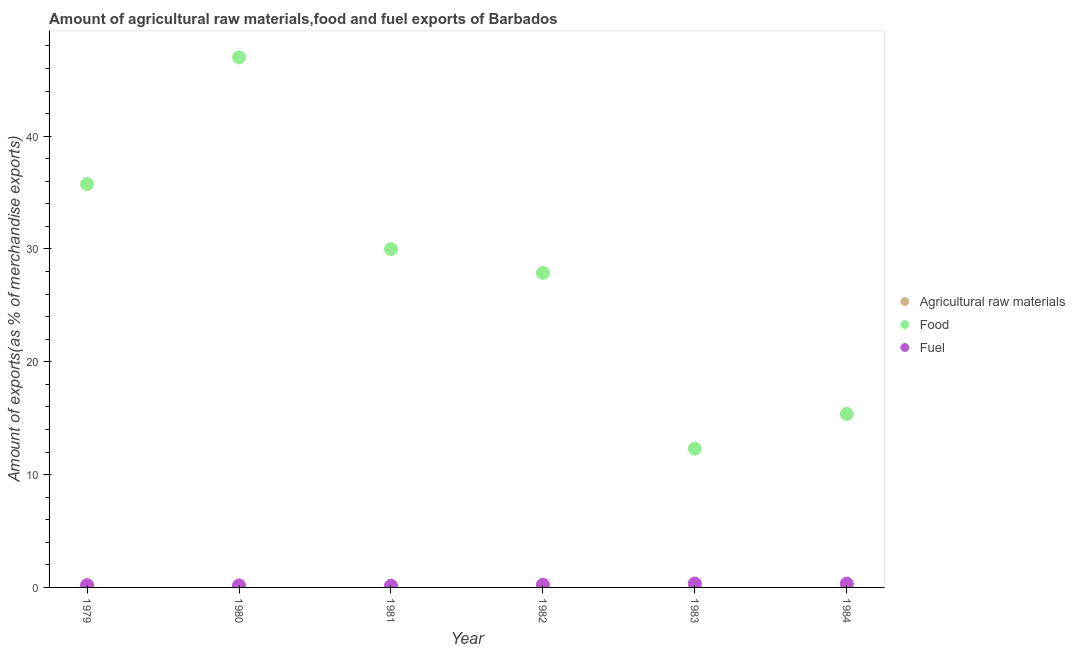What is the percentage of fuel exports in 1984?
Your answer should be very brief. 0.33. Across all years, what is the maximum percentage of raw materials exports?
Make the answer very short. 0.15. Across all years, what is the minimum percentage of food exports?
Your answer should be very brief. 12.3. In which year was the percentage of food exports minimum?
Ensure brevity in your answer.  1983. What is the total percentage of food exports in the graph?
Provide a short and direct response. 168.29. What is the difference between the percentage of raw materials exports in 1979 and that in 1981?
Keep it short and to the point. 0.13. What is the difference between the percentage of fuel exports in 1979 and the percentage of raw materials exports in 1984?
Your answer should be very brief. 0.19. What is the average percentage of raw materials exports per year?
Give a very brief answer. 0.04. In the year 1982, what is the difference between the percentage of raw materials exports and percentage of fuel exports?
Offer a terse response. -0.23. What is the ratio of the percentage of food exports in 1980 to that in 1983?
Provide a short and direct response. 3.82. Is the percentage of food exports in 1980 less than that in 1982?
Your answer should be compact. No. What is the difference between the highest and the second highest percentage of food exports?
Your answer should be compact. 11.24. What is the difference between the highest and the lowest percentage of raw materials exports?
Provide a short and direct response. 0.14. In how many years, is the percentage of food exports greater than the average percentage of food exports taken over all years?
Offer a very short reply. 3. Is it the case that in every year, the sum of the percentage of raw materials exports and percentage of food exports is greater than the percentage of fuel exports?
Make the answer very short. Yes. Is the percentage of raw materials exports strictly greater than the percentage of food exports over the years?
Make the answer very short. No. How many years are there in the graph?
Keep it short and to the point. 6. What is the difference between two consecutive major ticks on the Y-axis?
Make the answer very short. 10. Are the values on the major ticks of Y-axis written in scientific E-notation?
Make the answer very short. No. Does the graph contain any zero values?
Keep it short and to the point. No. Does the graph contain grids?
Ensure brevity in your answer.  No. What is the title of the graph?
Keep it short and to the point. Amount of agricultural raw materials,food and fuel exports of Barbados. Does "Taxes on international trade" appear as one of the legend labels in the graph?
Provide a short and direct response. No. What is the label or title of the X-axis?
Your answer should be very brief. Year. What is the label or title of the Y-axis?
Give a very brief answer. Amount of exports(as % of merchandise exports). What is the Amount of exports(as % of merchandise exports) in Agricultural raw materials in 1979?
Your answer should be compact. 0.15. What is the Amount of exports(as % of merchandise exports) in Food in 1979?
Your answer should be compact. 35.75. What is the Amount of exports(as % of merchandise exports) of Fuel in 1979?
Ensure brevity in your answer.  0.2. What is the Amount of exports(as % of merchandise exports) of Agricultural raw materials in 1980?
Make the answer very short. 0.06. What is the Amount of exports(as % of merchandise exports) in Food in 1980?
Your response must be concise. 46.99. What is the Amount of exports(as % of merchandise exports) of Fuel in 1980?
Your answer should be compact. 0.18. What is the Amount of exports(as % of merchandise exports) in Agricultural raw materials in 1981?
Make the answer very short. 0.02. What is the Amount of exports(as % of merchandise exports) in Food in 1981?
Offer a terse response. 29.98. What is the Amount of exports(as % of merchandise exports) of Fuel in 1981?
Ensure brevity in your answer.  0.15. What is the Amount of exports(as % of merchandise exports) of Agricultural raw materials in 1982?
Make the answer very short. 0.01. What is the Amount of exports(as % of merchandise exports) of Food in 1982?
Give a very brief answer. 27.88. What is the Amount of exports(as % of merchandise exports) of Fuel in 1982?
Keep it short and to the point. 0.24. What is the Amount of exports(as % of merchandise exports) of Agricultural raw materials in 1983?
Keep it short and to the point. 0.01. What is the Amount of exports(as % of merchandise exports) in Food in 1983?
Keep it short and to the point. 12.3. What is the Amount of exports(as % of merchandise exports) in Fuel in 1983?
Keep it short and to the point. 0.35. What is the Amount of exports(as % of merchandise exports) in Agricultural raw materials in 1984?
Keep it short and to the point. 0.01. What is the Amount of exports(as % of merchandise exports) in Food in 1984?
Make the answer very short. 15.38. What is the Amount of exports(as % of merchandise exports) in Fuel in 1984?
Ensure brevity in your answer.  0.33. Across all years, what is the maximum Amount of exports(as % of merchandise exports) in Agricultural raw materials?
Offer a terse response. 0.15. Across all years, what is the maximum Amount of exports(as % of merchandise exports) in Food?
Your answer should be very brief. 46.99. Across all years, what is the maximum Amount of exports(as % of merchandise exports) of Fuel?
Provide a short and direct response. 0.35. Across all years, what is the minimum Amount of exports(as % of merchandise exports) in Agricultural raw materials?
Your answer should be compact. 0.01. Across all years, what is the minimum Amount of exports(as % of merchandise exports) in Food?
Your answer should be compact. 12.3. Across all years, what is the minimum Amount of exports(as % of merchandise exports) of Fuel?
Make the answer very short. 0.15. What is the total Amount of exports(as % of merchandise exports) in Agricultural raw materials in the graph?
Your response must be concise. 0.26. What is the total Amount of exports(as % of merchandise exports) of Food in the graph?
Provide a short and direct response. 168.29. What is the total Amount of exports(as % of merchandise exports) of Fuel in the graph?
Your answer should be very brief. 1.45. What is the difference between the Amount of exports(as % of merchandise exports) of Agricultural raw materials in 1979 and that in 1980?
Give a very brief answer. 0.09. What is the difference between the Amount of exports(as % of merchandise exports) in Food in 1979 and that in 1980?
Make the answer very short. -11.24. What is the difference between the Amount of exports(as % of merchandise exports) of Fuel in 1979 and that in 1980?
Your answer should be very brief. 0.02. What is the difference between the Amount of exports(as % of merchandise exports) in Agricultural raw materials in 1979 and that in 1981?
Your response must be concise. 0.13. What is the difference between the Amount of exports(as % of merchandise exports) of Food in 1979 and that in 1981?
Your response must be concise. 5.76. What is the difference between the Amount of exports(as % of merchandise exports) of Fuel in 1979 and that in 1981?
Make the answer very short. 0.05. What is the difference between the Amount of exports(as % of merchandise exports) in Agricultural raw materials in 1979 and that in 1982?
Your answer should be compact. 0.14. What is the difference between the Amount of exports(as % of merchandise exports) of Food in 1979 and that in 1982?
Your answer should be compact. 7.87. What is the difference between the Amount of exports(as % of merchandise exports) of Fuel in 1979 and that in 1982?
Make the answer very short. -0.04. What is the difference between the Amount of exports(as % of merchandise exports) in Agricultural raw materials in 1979 and that in 1983?
Offer a terse response. 0.14. What is the difference between the Amount of exports(as % of merchandise exports) of Food in 1979 and that in 1983?
Ensure brevity in your answer.  23.44. What is the difference between the Amount of exports(as % of merchandise exports) of Fuel in 1979 and that in 1983?
Give a very brief answer. -0.15. What is the difference between the Amount of exports(as % of merchandise exports) of Agricultural raw materials in 1979 and that in 1984?
Offer a terse response. 0.14. What is the difference between the Amount of exports(as % of merchandise exports) of Food in 1979 and that in 1984?
Ensure brevity in your answer.  20.37. What is the difference between the Amount of exports(as % of merchandise exports) in Fuel in 1979 and that in 1984?
Provide a succinct answer. -0.13. What is the difference between the Amount of exports(as % of merchandise exports) of Agricultural raw materials in 1980 and that in 1981?
Give a very brief answer. 0.04. What is the difference between the Amount of exports(as % of merchandise exports) in Food in 1980 and that in 1981?
Your answer should be very brief. 17.01. What is the difference between the Amount of exports(as % of merchandise exports) of Fuel in 1980 and that in 1981?
Ensure brevity in your answer.  0.02. What is the difference between the Amount of exports(as % of merchandise exports) of Agricultural raw materials in 1980 and that in 1982?
Keep it short and to the point. 0.05. What is the difference between the Amount of exports(as % of merchandise exports) of Food in 1980 and that in 1982?
Keep it short and to the point. 19.11. What is the difference between the Amount of exports(as % of merchandise exports) of Fuel in 1980 and that in 1982?
Offer a terse response. -0.06. What is the difference between the Amount of exports(as % of merchandise exports) in Agricultural raw materials in 1980 and that in 1983?
Your answer should be very brief. 0.05. What is the difference between the Amount of exports(as % of merchandise exports) in Food in 1980 and that in 1983?
Offer a very short reply. 34.68. What is the difference between the Amount of exports(as % of merchandise exports) of Fuel in 1980 and that in 1983?
Provide a short and direct response. -0.17. What is the difference between the Amount of exports(as % of merchandise exports) of Agricultural raw materials in 1980 and that in 1984?
Give a very brief answer. 0.05. What is the difference between the Amount of exports(as % of merchandise exports) of Food in 1980 and that in 1984?
Provide a succinct answer. 31.61. What is the difference between the Amount of exports(as % of merchandise exports) in Fuel in 1980 and that in 1984?
Offer a terse response. -0.15. What is the difference between the Amount of exports(as % of merchandise exports) in Food in 1981 and that in 1982?
Offer a very short reply. 2.1. What is the difference between the Amount of exports(as % of merchandise exports) of Fuel in 1981 and that in 1982?
Ensure brevity in your answer.  -0.09. What is the difference between the Amount of exports(as % of merchandise exports) of Agricultural raw materials in 1981 and that in 1983?
Offer a very short reply. 0.01. What is the difference between the Amount of exports(as % of merchandise exports) of Food in 1981 and that in 1983?
Ensure brevity in your answer.  17.68. What is the difference between the Amount of exports(as % of merchandise exports) of Fuel in 1981 and that in 1983?
Provide a succinct answer. -0.19. What is the difference between the Amount of exports(as % of merchandise exports) of Agricultural raw materials in 1981 and that in 1984?
Keep it short and to the point. 0.01. What is the difference between the Amount of exports(as % of merchandise exports) of Food in 1981 and that in 1984?
Keep it short and to the point. 14.6. What is the difference between the Amount of exports(as % of merchandise exports) in Fuel in 1981 and that in 1984?
Offer a terse response. -0.18. What is the difference between the Amount of exports(as % of merchandise exports) of Agricultural raw materials in 1982 and that in 1983?
Make the answer very short. 0. What is the difference between the Amount of exports(as % of merchandise exports) in Food in 1982 and that in 1983?
Provide a succinct answer. 15.58. What is the difference between the Amount of exports(as % of merchandise exports) in Fuel in 1982 and that in 1983?
Provide a short and direct response. -0.11. What is the difference between the Amount of exports(as % of merchandise exports) in Agricultural raw materials in 1982 and that in 1984?
Give a very brief answer. -0. What is the difference between the Amount of exports(as % of merchandise exports) in Food in 1982 and that in 1984?
Make the answer very short. 12.5. What is the difference between the Amount of exports(as % of merchandise exports) in Fuel in 1982 and that in 1984?
Offer a very short reply. -0.09. What is the difference between the Amount of exports(as % of merchandise exports) of Agricultural raw materials in 1983 and that in 1984?
Your answer should be compact. -0. What is the difference between the Amount of exports(as % of merchandise exports) in Food in 1983 and that in 1984?
Your answer should be very brief. -3.08. What is the difference between the Amount of exports(as % of merchandise exports) in Fuel in 1983 and that in 1984?
Keep it short and to the point. 0.02. What is the difference between the Amount of exports(as % of merchandise exports) in Agricultural raw materials in 1979 and the Amount of exports(as % of merchandise exports) in Food in 1980?
Your answer should be compact. -46.84. What is the difference between the Amount of exports(as % of merchandise exports) in Agricultural raw materials in 1979 and the Amount of exports(as % of merchandise exports) in Fuel in 1980?
Keep it short and to the point. -0.03. What is the difference between the Amount of exports(as % of merchandise exports) of Food in 1979 and the Amount of exports(as % of merchandise exports) of Fuel in 1980?
Keep it short and to the point. 35.57. What is the difference between the Amount of exports(as % of merchandise exports) of Agricultural raw materials in 1979 and the Amount of exports(as % of merchandise exports) of Food in 1981?
Give a very brief answer. -29.83. What is the difference between the Amount of exports(as % of merchandise exports) in Agricultural raw materials in 1979 and the Amount of exports(as % of merchandise exports) in Fuel in 1981?
Ensure brevity in your answer.  -0. What is the difference between the Amount of exports(as % of merchandise exports) in Food in 1979 and the Amount of exports(as % of merchandise exports) in Fuel in 1981?
Provide a short and direct response. 35.6. What is the difference between the Amount of exports(as % of merchandise exports) of Agricultural raw materials in 1979 and the Amount of exports(as % of merchandise exports) of Food in 1982?
Give a very brief answer. -27.73. What is the difference between the Amount of exports(as % of merchandise exports) of Agricultural raw materials in 1979 and the Amount of exports(as % of merchandise exports) of Fuel in 1982?
Give a very brief answer. -0.09. What is the difference between the Amount of exports(as % of merchandise exports) of Food in 1979 and the Amount of exports(as % of merchandise exports) of Fuel in 1982?
Give a very brief answer. 35.51. What is the difference between the Amount of exports(as % of merchandise exports) of Agricultural raw materials in 1979 and the Amount of exports(as % of merchandise exports) of Food in 1983?
Your answer should be compact. -12.16. What is the difference between the Amount of exports(as % of merchandise exports) of Agricultural raw materials in 1979 and the Amount of exports(as % of merchandise exports) of Fuel in 1983?
Your answer should be very brief. -0.2. What is the difference between the Amount of exports(as % of merchandise exports) of Food in 1979 and the Amount of exports(as % of merchandise exports) of Fuel in 1983?
Ensure brevity in your answer.  35.4. What is the difference between the Amount of exports(as % of merchandise exports) of Agricultural raw materials in 1979 and the Amount of exports(as % of merchandise exports) of Food in 1984?
Provide a short and direct response. -15.23. What is the difference between the Amount of exports(as % of merchandise exports) of Agricultural raw materials in 1979 and the Amount of exports(as % of merchandise exports) of Fuel in 1984?
Your response must be concise. -0.18. What is the difference between the Amount of exports(as % of merchandise exports) of Food in 1979 and the Amount of exports(as % of merchandise exports) of Fuel in 1984?
Give a very brief answer. 35.42. What is the difference between the Amount of exports(as % of merchandise exports) in Agricultural raw materials in 1980 and the Amount of exports(as % of merchandise exports) in Food in 1981?
Offer a terse response. -29.93. What is the difference between the Amount of exports(as % of merchandise exports) of Agricultural raw materials in 1980 and the Amount of exports(as % of merchandise exports) of Fuel in 1981?
Your answer should be very brief. -0.09. What is the difference between the Amount of exports(as % of merchandise exports) in Food in 1980 and the Amount of exports(as % of merchandise exports) in Fuel in 1981?
Make the answer very short. 46.84. What is the difference between the Amount of exports(as % of merchandise exports) in Agricultural raw materials in 1980 and the Amount of exports(as % of merchandise exports) in Food in 1982?
Give a very brief answer. -27.82. What is the difference between the Amount of exports(as % of merchandise exports) in Agricultural raw materials in 1980 and the Amount of exports(as % of merchandise exports) in Fuel in 1982?
Provide a short and direct response. -0.18. What is the difference between the Amount of exports(as % of merchandise exports) in Food in 1980 and the Amount of exports(as % of merchandise exports) in Fuel in 1982?
Make the answer very short. 46.75. What is the difference between the Amount of exports(as % of merchandise exports) of Agricultural raw materials in 1980 and the Amount of exports(as % of merchandise exports) of Food in 1983?
Your answer should be very brief. -12.25. What is the difference between the Amount of exports(as % of merchandise exports) in Agricultural raw materials in 1980 and the Amount of exports(as % of merchandise exports) in Fuel in 1983?
Make the answer very short. -0.29. What is the difference between the Amount of exports(as % of merchandise exports) of Food in 1980 and the Amount of exports(as % of merchandise exports) of Fuel in 1983?
Keep it short and to the point. 46.64. What is the difference between the Amount of exports(as % of merchandise exports) of Agricultural raw materials in 1980 and the Amount of exports(as % of merchandise exports) of Food in 1984?
Offer a terse response. -15.32. What is the difference between the Amount of exports(as % of merchandise exports) of Agricultural raw materials in 1980 and the Amount of exports(as % of merchandise exports) of Fuel in 1984?
Offer a very short reply. -0.27. What is the difference between the Amount of exports(as % of merchandise exports) of Food in 1980 and the Amount of exports(as % of merchandise exports) of Fuel in 1984?
Your response must be concise. 46.66. What is the difference between the Amount of exports(as % of merchandise exports) of Agricultural raw materials in 1981 and the Amount of exports(as % of merchandise exports) of Food in 1982?
Make the answer very short. -27.86. What is the difference between the Amount of exports(as % of merchandise exports) of Agricultural raw materials in 1981 and the Amount of exports(as % of merchandise exports) of Fuel in 1982?
Your answer should be very brief. -0.22. What is the difference between the Amount of exports(as % of merchandise exports) of Food in 1981 and the Amount of exports(as % of merchandise exports) of Fuel in 1982?
Ensure brevity in your answer.  29.74. What is the difference between the Amount of exports(as % of merchandise exports) in Agricultural raw materials in 1981 and the Amount of exports(as % of merchandise exports) in Food in 1983?
Provide a short and direct response. -12.28. What is the difference between the Amount of exports(as % of merchandise exports) of Agricultural raw materials in 1981 and the Amount of exports(as % of merchandise exports) of Fuel in 1983?
Make the answer very short. -0.33. What is the difference between the Amount of exports(as % of merchandise exports) of Food in 1981 and the Amount of exports(as % of merchandise exports) of Fuel in 1983?
Make the answer very short. 29.64. What is the difference between the Amount of exports(as % of merchandise exports) in Agricultural raw materials in 1981 and the Amount of exports(as % of merchandise exports) in Food in 1984?
Your answer should be compact. -15.36. What is the difference between the Amount of exports(as % of merchandise exports) in Agricultural raw materials in 1981 and the Amount of exports(as % of merchandise exports) in Fuel in 1984?
Provide a short and direct response. -0.31. What is the difference between the Amount of exports(as % of merchandise exports) of Food in 1981 and the Amount of exports(as % of merchandise exports) of Fuel in 1984?
Offer a very short reply. 29.65. What is the difference between the Amount of exports(as % of merchandise exports) of Agricultural raw materials in 1982 and the Amount of exports(as % of merchandise exports) of Food in 1983?
Your answer should be very brief. -12.29. What is the difference between the Amount of exports(as % of merchandise exports) of Agricultural raw materials in 1982 and the Amount of exports(as % of merchandise exports) of Fuel in 1983?
Ensure brevity in your answer.  -0.34. What is the difference between the Amount of exports(as % of merchandise exports) of Food in 1982 and the Amount of exports(as % of merchandise exports) of Fuel in 1983?
Give a very brief answer. 27.53. What is the difference between the Amount of exports(as % of merchandise exports) in Agricultural raw materials in 1982 and the Amount of exports(as % of merchandise exports) in Food in 1984?
Make the answer very short. -15.37. What is the difference between the Amount of exports(as % of merchandise exports) of Agricultural raw materials in 1982 and the Amount of exports(as % of merchandise exports) of Fuel in 1984?
Your response must be concise. -0.32. What is the difference between the Amount of exports(as % of merchandise exports) in Food in 1982 and the Amount of exports(as % of merchandise exports) in Fuel in 1984?
Provide a short and direct response. 27.55. What is the difference between the Amount of exports(as % of merchandise exports) of Agricultural raw materials in 1983 and the Amount of exports(as % of merchandise exports) of Food in 1984?
Your answer should be very brief. -15.37. What is the difference between the Amount of exports(as % of merchandise exports) of Agricultural raw materials in 1983 and the Amount of exports(as % of merchandise exports) of Fuel in 1984?
Provide a short and direct response. -0.32. What is the difference between the Amount of exports(as % of merchandise exports) of Food in 1983 and the Amount of exports(as % of merchandise exports) of Fuel in 1984?
Make the answer very short. 11.97. What is the average Amount of exports(as % of merchandise exports) in Agricultural raw materials per year?
Ensure brevity in your answer.  0.04. What is the average Amount of exports(as % of merchandise exports) of Food per year?
Keep it short and to the point. 28.05. What is the average Amount of exports(as % of merchandise exports) in Fuel per year?
Offer a terse response. 0.24. In the year 1979, what is the difference between the Amount of exports(as % of merchandise exports) in Agricultural raw materials and Amount of exports(as % of merchandise exports) in Food?
Ensure brevity in your answer.  -35.6. In the year 1979, what is the difference between the Amount of exports(as % of merchandise exports) in Agricultural raw materials and Amount of exports(as % of merchandise exports) in Fuel?
Keep it short and to the point. -0.05. In the year 1979, what is the difference between the Amount of exports(as % of merchandise exports) of Food and Amount of exports(as % of merchandise exports) of Fuel?
Ensure brevity in your answer.  35.55. In the year 1980, what is the difference between the Amount of exports(as % of merchandise exports) in Agricultural raw materials and Amount of exports(as % of merchandise exports) in Food?
Provide a short and direct response. -46.93. In the year 1980, what is the difference between the Amount of exports(as % of merchandise exports) of Agricultural raw materials and Amount of exports(as % of merchandise exports) of Fuel?
Your answer should be very brief. -0.12. In the year 1980, what is the difference between the Amount of exports(as % of merchandise exports) in Food and Amount of exports(as % of merchandise exports) in Fuel?
Offer a terse response. 46.81. In the year 1981, what is the difference between the Amount of exports(as % of merchandise exports) of Agricultural raw materials and Amount of exports(as % of merchandise exports) of Food?
Provide a short and direct response. -29.96. In the year 1981, what is the difference between the Amount of exports(as % of merchandise exports) in Agricultural raw materials and Amount of exports(as % of merchandise exports) in Fuel?
Provide a short and direct response. -0.13. In the year 1981, what is the difference between the Amount of exports(as % of merchandise exports) in Food and Amount of exports(as % of merchandise exports) in Fuel?
Offer a terse response. 29.83. In the year 1982, what is the difference between the Amount of exports(as % of merchandise exports) in Agricultural raw materials and Amount of exports(as % of merchandise exports) in Food?
Give a very brief answer. -27.87. In the year 1982, what is the difference between the Amount of exports(as % of merchandise exports) of Agricultural raw materials and Amount of exports(as % of merchandise exports) of Fuel?
Your answer should be compact. -0.23. In the year 1982, what is the difference between the Amount of exports(as % of merchandise exports) of Food and Amount of exports(as % of merchandise exports) of Fuel?
Ensure brevity in your answer.  27.64. In the year 1983, what is the difference between the Amount of exports(as % of merchandise exports) of Agricultural raw materials and Amount of exports(as % of merchandise exports) of Food?
Your response must be concise. -12.3. In the year 1983, what is the difference between the Amount of exports(as % of merchandise exports) in Agricultural raw materials and Amount of exports(as % of merchandise exports) in Fuel?
Provide a succinct answer. -0.34. In the year 1983, what is the difference between the Amount of exports(as % of merchandise exports) of Food and Amount of exports(as % of merchandise exports) of Fuel?
Keep it short and to the point. 11.96. In the year 1984, what is the difference between the Amount of exports(as % of merchandise exports) in Agricultural raw materials and Amount of exports(as % of merchandise exports) in Food?
Keep it short and to the point. -15.37. In the year 1984, what is the difference between the Amount of exports(as % of merchandise exports) of Agricultural raw materials and Amount of exports(as % of merchandise exports) of Fuel?
Keep it short and to the point. -0.32. In the year 1984, what is the difference between the Amount of exports(as % of merchandise exports) of Food and Amount of exports(as % of merchandise exports) of Fuel?
Provide a short and direct response. 15.05. What is the ratio of the Amount of exports(as % of merchandise exports) of Agricultural raw materials in 1979 to that in 1980?
Your answer should be compact. 2.56. What is the ratio of the Amount of exports(as % of merchandise exports) of Food in 1979 to that in 1980?
Ensure brevity in your answer.  0.76. What is the ratio of the Amount of exports(as % of merchandise exports) in Fuel in 1979 to that in 1980?
Offer a very short reply. 1.13. What is the ratio of the Amount of exports(as % of merchandise exports) of Agricultural raw materials in 1979 to that in 1981?
Offer a very short reply. 7.41. What is the ratio of the Amount of exports(as % of merchandise exports) of Food in 1979 to that in 1981?
Offer a terse response. 1.19. What is the ratio of the Amount of exports(as % of merchandise exports) in Fuel in 1979 to that in 1981?
Give a very brief answer. 1.31. What is the ratio of the Amount of exports(as % of merchandise exports) of Agricultural raw materials in 1979 to that in 1982?
Your response must be concise. 14.71. What is the ratio of the Amount of exports(as % of merchandise exports) in Food in 1979 to that in 1982?
Provide a succinct answer. 1.28. What is the ratio of the Amount of exports(as % of merchandise exports) in Fuel in 1979 to that in 1982?
Ensure brevity in your answer.  0.83. What is the ratio of the Amount of exports(as % of merchandise exports) in Agricultural raw materials in 1979 to that in 1983?
Provide a succinct answer. 20.27. What is the ratio of the Amount of exports(as % of merchandise exports) in Food in 1979 to that in 1983?
Offer a terse response. 2.91. What is the ratio of the Amount of exports(as % of merchandise exports) in Fuel in 1979 to that in 1983?
Keep it short and to the point. 0.57. What is the ratio of the Amount of exports(as % of merchandise exports) in Agricultural raw materials in 1979 to that in 1984?
Provide a succinct answer. 13.71. What is the ratio of the Amount of exports(as % of merchandise exports) in Food in 1979 to that in 1984?
Provide a succinct answer. 2.32. What is the ratio of the Amount of exports(as % of merchandise exports) of Fuel in 1979 to that in 1984?
Your answer should be very brief. 0.6. What is the ratio of the Amount of exports(as % of merchandise exports) of Agricultural raw materials in 1980 to that in 1981?
Make the answer very short. 2.9. What is the ratio of the Amount of exports(as % of merchandise exports) in Food in 1980 to that in 1981?
Make the answer very short. 1.57. What is the ratio of the Amount of exports(as % of merchandise exports) in Fuel in 1980 to that in 1981?
Your answer should be very brief. 1.16. What is the ratio of the Amount of exports(as % of merchandise exports) of Agricultural raw materials in 1980 to that in 1982?
Ensure brevity in your answer.  5.75. What is the ratio of the Amount of exports(as % of merchandise exports) of Food in 1980 to that in 1982?
Your response must be concise. 1.69. What is the ratio of the Amount of exports(as % of merchandise exports) of Fuel in 1980 to that in 1982?
Give a very brief answer. 0.73. What is the ratio of the Amount of exports(as % of merchandise exports) of Agricultural raw materials in 1980 to that in 1983?
Offer a very short reply. 7.92. What is the ratio of the Amount of exports(as % of merchandise exports) in Food in 1980 to that in 1983?
Provide a succinct answer. 3.82. What is the ratio of the Amount of exports(as % of merchandise exports) of Fuel in 1980 to that in 1983?
Your response must be concise. 0.51. What is the ratio of the Amount of exports(as % of merchandise exports) in Agricultural raw materials in 1980 to that in 1984?
Make the answer very short. 5.36. What is the ratio of the Amount of exports(as % of merchandise exports) in Food in 1980 to that in 1984?
Offer a terse response. 3.05. What is the ratio of the Amount of exports(as % of merchandise exports) in Fuel in 1980 to that in 1984?
Your answer should be compact. 0.53. What is the ratio of the Amount of exports(as % of merchandise exports) of Agricultural raw materials in 1981 to that in 1982?
Provide a succinct answer. 1.99. What is the ratio of the Amount of exports(as % of merchandise exports) in Food in 1981 to that in 1982?
Ensure brevity in your answer.  1.08. What is the ratio of the Amount of exports(as % of merchandise exports) of Fuel in 1981 to that in 1982?
Offer a very short reply. 0.63. What is the ratio of the Amount of exports(as % of merchandise exports) of Agricultural raw materials in 1981 to that in 1983?
Offer a very short reply. 2.74. What is the ratio of the Amount of exports(as % of merchandise exports) in Food in 1981 to that in 1983?
Offer a terse response. 2.44. What is the ratio of the Amount of exports(as % of merchandise exports) of Fuel in 1981 to that in 1983?
Keep it short and to the point. 0.44. What is the ratio of the Amount of exports(as % of merchandise exports) of Agricultural raw materials in 1981 to that in 1984?
Keep it short and to the point. 1.85. What is the ratio of the Amount of exports(as % of merchandise exports) in Food in 1981 to that in 1984?
Offer a very short reply. 1.95. What is the ratio of the Amount of exports(as % of merchandise exports) in Fuel in 1981 to that in 1984?
Offer a terse response. 0.46. What is the ratio of the Amount of exports(as % of merchandise exports) of Agricultural raw materials in 1982 to that in 1983?
Give a very brief answer. 1.38. What is the ratio of the Amount of exports(as % of merchandise exports) of Food in 1982 to that in 1983?
Offer a very short reply. 2.27. What is the ratio of the Amount of exports(as % of merchandise exports) in Fuel in 1982 to that in 1983?
Offer a terse response. 0.69. What is the ratio of the Amount of exports(as % of merchandise exports) of Agricultural raw materials in 1982 to that in 1984?
Provide a succinct answer. 0.93. What is the ratio of the Amount of exports(as % of merchandise exports) of Food in 1982 to that in 1984?
Offer a terse response. 1.81. What is the ratio of the Amount of exports(as % of merchandise exports) in Fuel in 1982 to that in 1984?
Provide a short and direct response. 0.73. What is the ratio of the Amount of exports(as % of merchandise exports) of Agricultural raw materials in 1983 to that in 1984?
Provide a short and direct response. 0.68. What is the ratio of the Amount of exports(as % of merchandise exports) in Food in 1983 to that in 1984?
Provide a succinct answer. 0.8. What is the ratio of the Amount of exports(as % of merchandise exports) in Fuel in 1983 to that in 1984?
Offer a very short reply. 1.05. What is the difference between the highest and the second highest Amount of exports(as % of merchandise exports) of Agricultural raw materials?
Your answer should be very brief. 0.09. What is the difference between the highest and the second highest Amount of exports(as % of merchandise exports) of Food?
Provide a succinct answer. 11.24. What is the difference between the highest and the second highest Amount of exports(as % of merchandise exports) in Fuel?
Offer a very short reply. 0.02. What is the difference between the highest and the lowest Amount of exports(as % of merchandise exports) of Agricultural raw materials?
Your response must be concise. 0.14. What is the difference between the highest and the lowest Amount of exports(as % of merchandise exports) of Food?
Your response must be concise. 34.68. What is the difference between the highest and the lowest Amount of exports(as % of merchandise exports) of Fuel?
Provide a short and direct response. 0.19. 